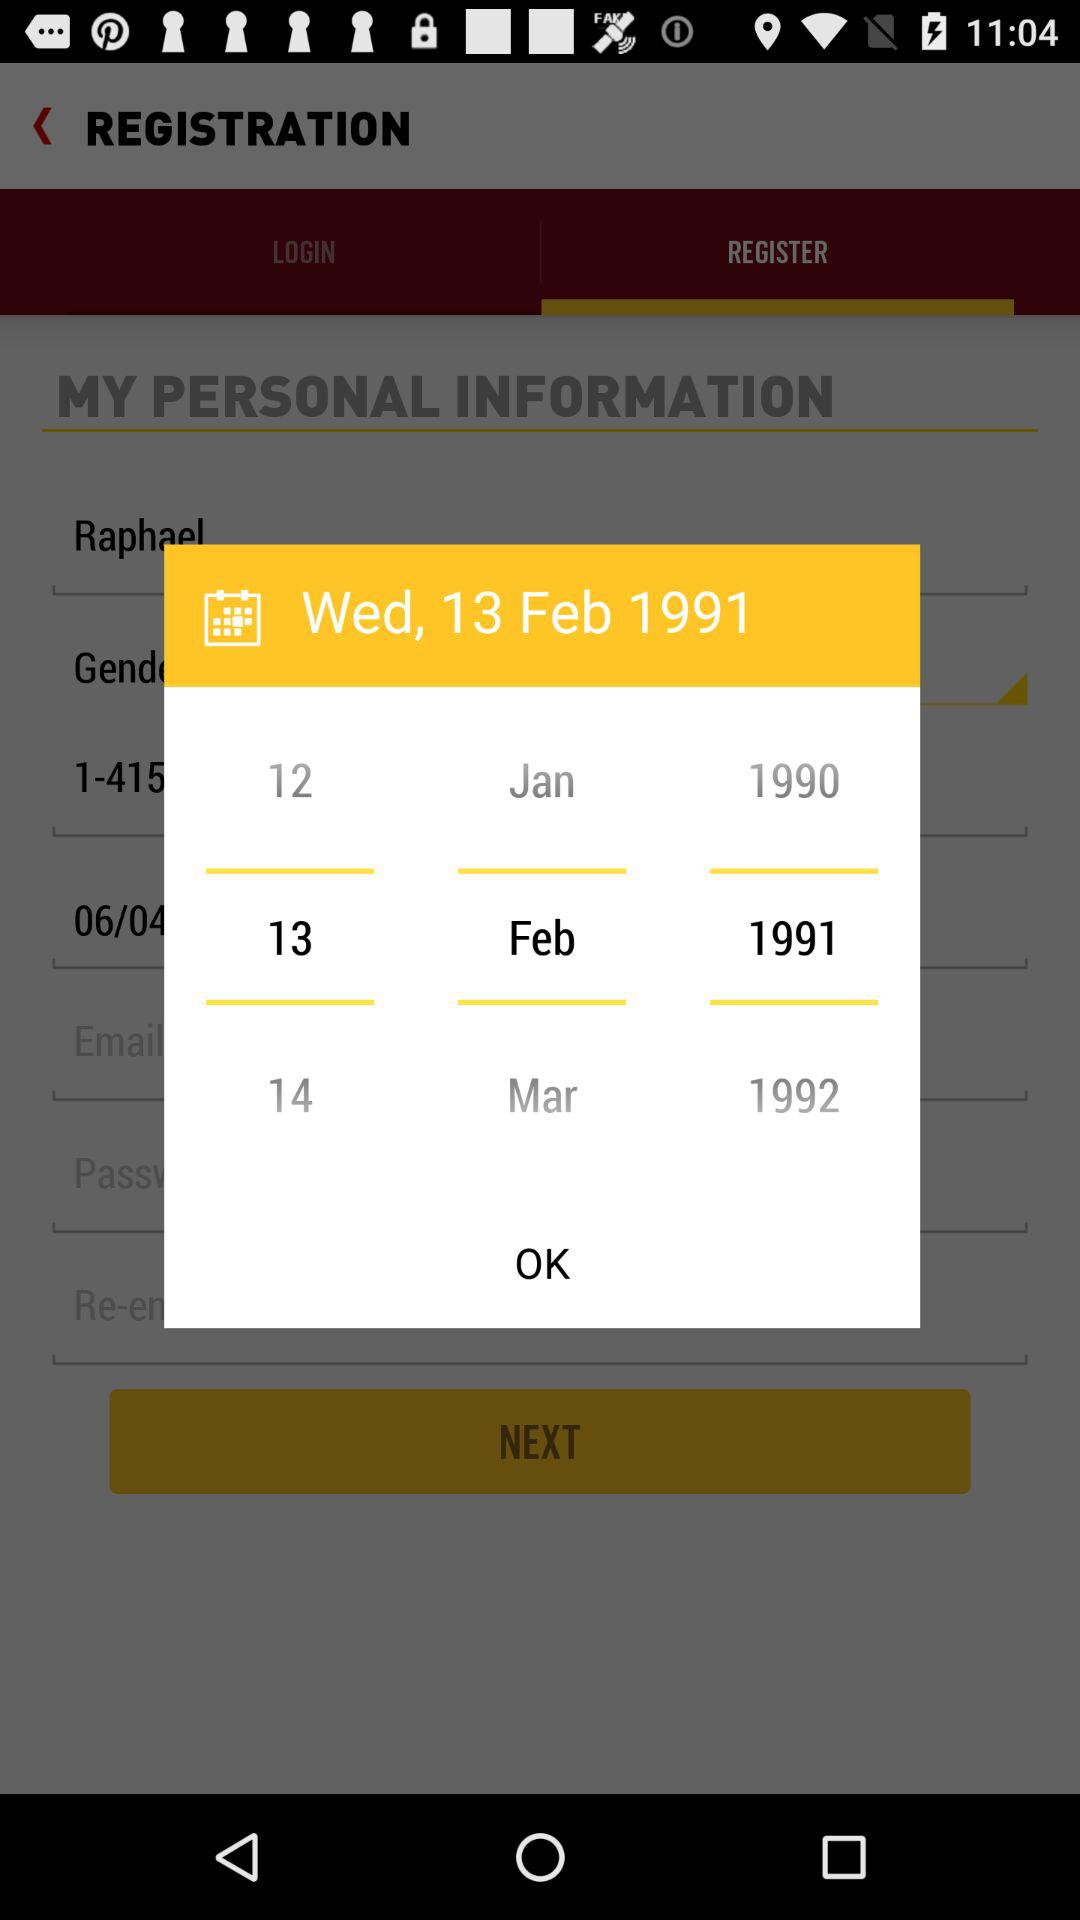How many years are shown on the calendar?
Answer the question using a single word or phrase. 3 